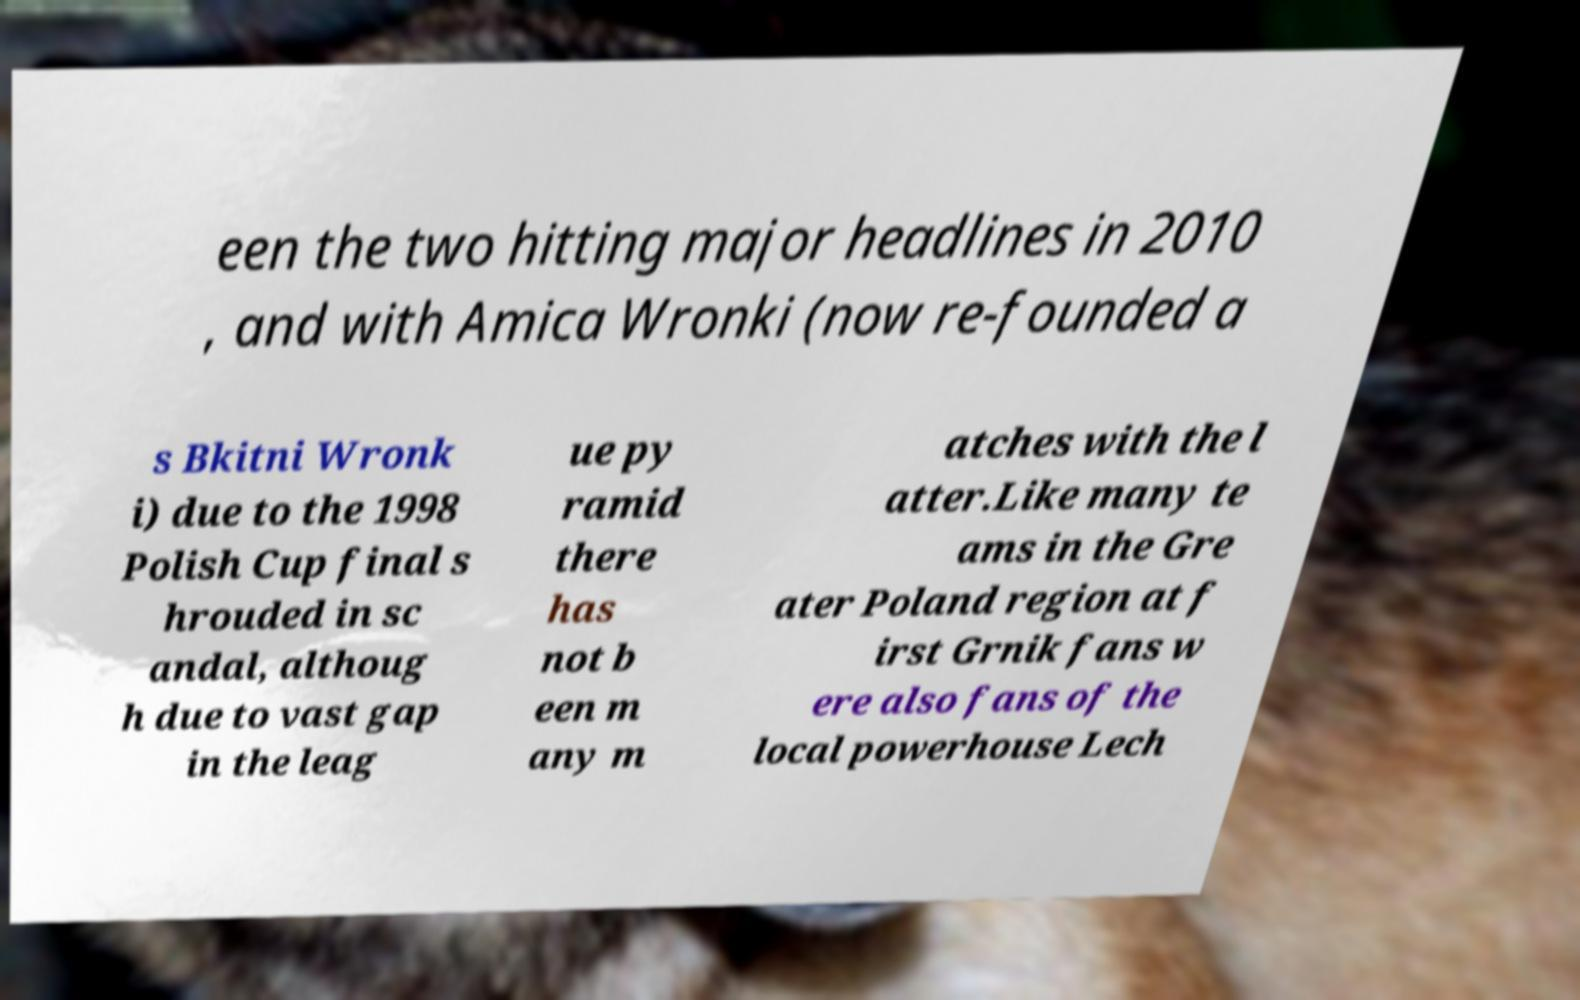What messages or text are displayed in this image? I need them in a readable, typed format. een the two hitting major headlines in 2010 , and with Amica Wronki (now re-founded a s Bkitni Wronk i) due to the 1998 Polish Cup final s hrouded in sc andal, althoug h due to vast gap in the leag ue py ramid there has not b een m any m atches with the l atter.Like many te ams in the Gre ater Poland region at f irst Grnik fans w ere also fans of the local powerhouse Lech 